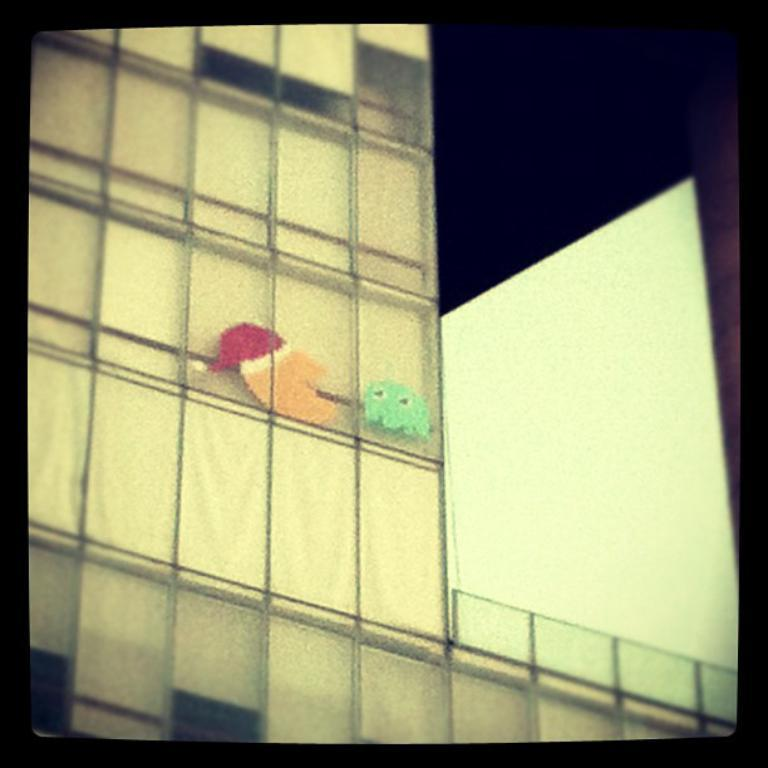What is the main subject of the image? There is a painting in the image. What is depicted in the painting? The painting depicts two birds. Where is the painting located? The painting is on a building. What type of tree is depicted in the painting? There is no tree depicted in the painting; it features two birds. What year does the battle depicted in the painting take place? There is no battle depicted in the painting; it features two birds. 